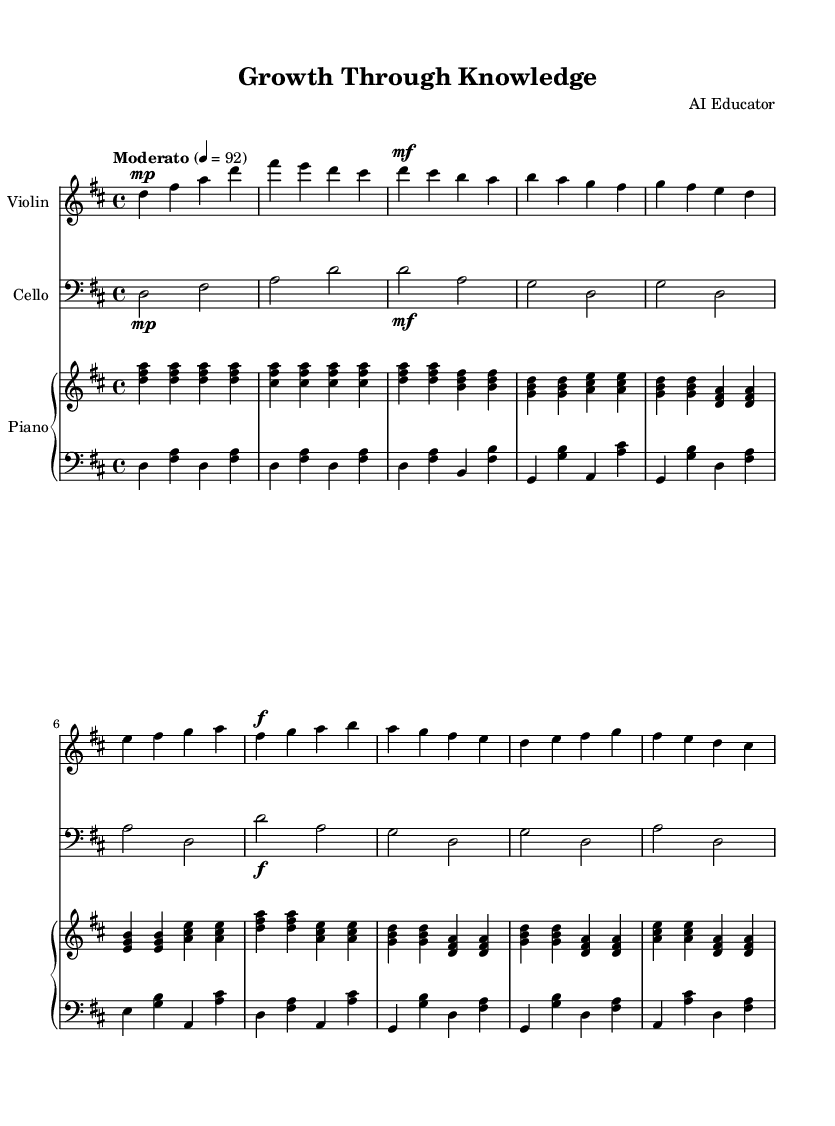What is the key signature of this music? The key signature is D major, which contains two sharps: F sharp and C sharp. This is indicated at the beginning of the sheet music.
Answer: D major What is the time signature of this piece? The time signature is 4/4, meaning there are four beats in a measure and the quarter note receives one beat. This is shown at the beginning of the score.
Answer: 4/4 What is the tempo marking for this composition? The tempo marking is "Moderato," which indicates a moderate speed for the piece, set at a quarter note equal to 92 beats per minute. This is specified above the music staff.
Answer: Moderato How many measures are in the Introduction section of the music? The Introduction section has two measures, as indicated by the measure lines before the themes start. By counting the measures notated in this section, we confirm there are two.
Answer: 2 Which instrument plays the highest part in this score? The highest part is played by the violin, as it is notated in the treble clef and typically plays higher notes than the cello and piano. This can be identified by looking at the clef and range of the notes.
Answer: Violin What dynamics are indicated at the beginning of Theme A for the cello? The dynamics indicated at the beginning of Theme A for the cello is "mf," which stands for mezzo-forte, meaning moderately loud. This is noted in the score before the theme starts.
Answer: mf What is the last note value of the Theme B in the violin part? The last note value of Theme B in the violin part is a quarter note. By analyzing the notation at the end of Theme B, we find the final note is a quarter note in duration.
Answer: Quarter note 